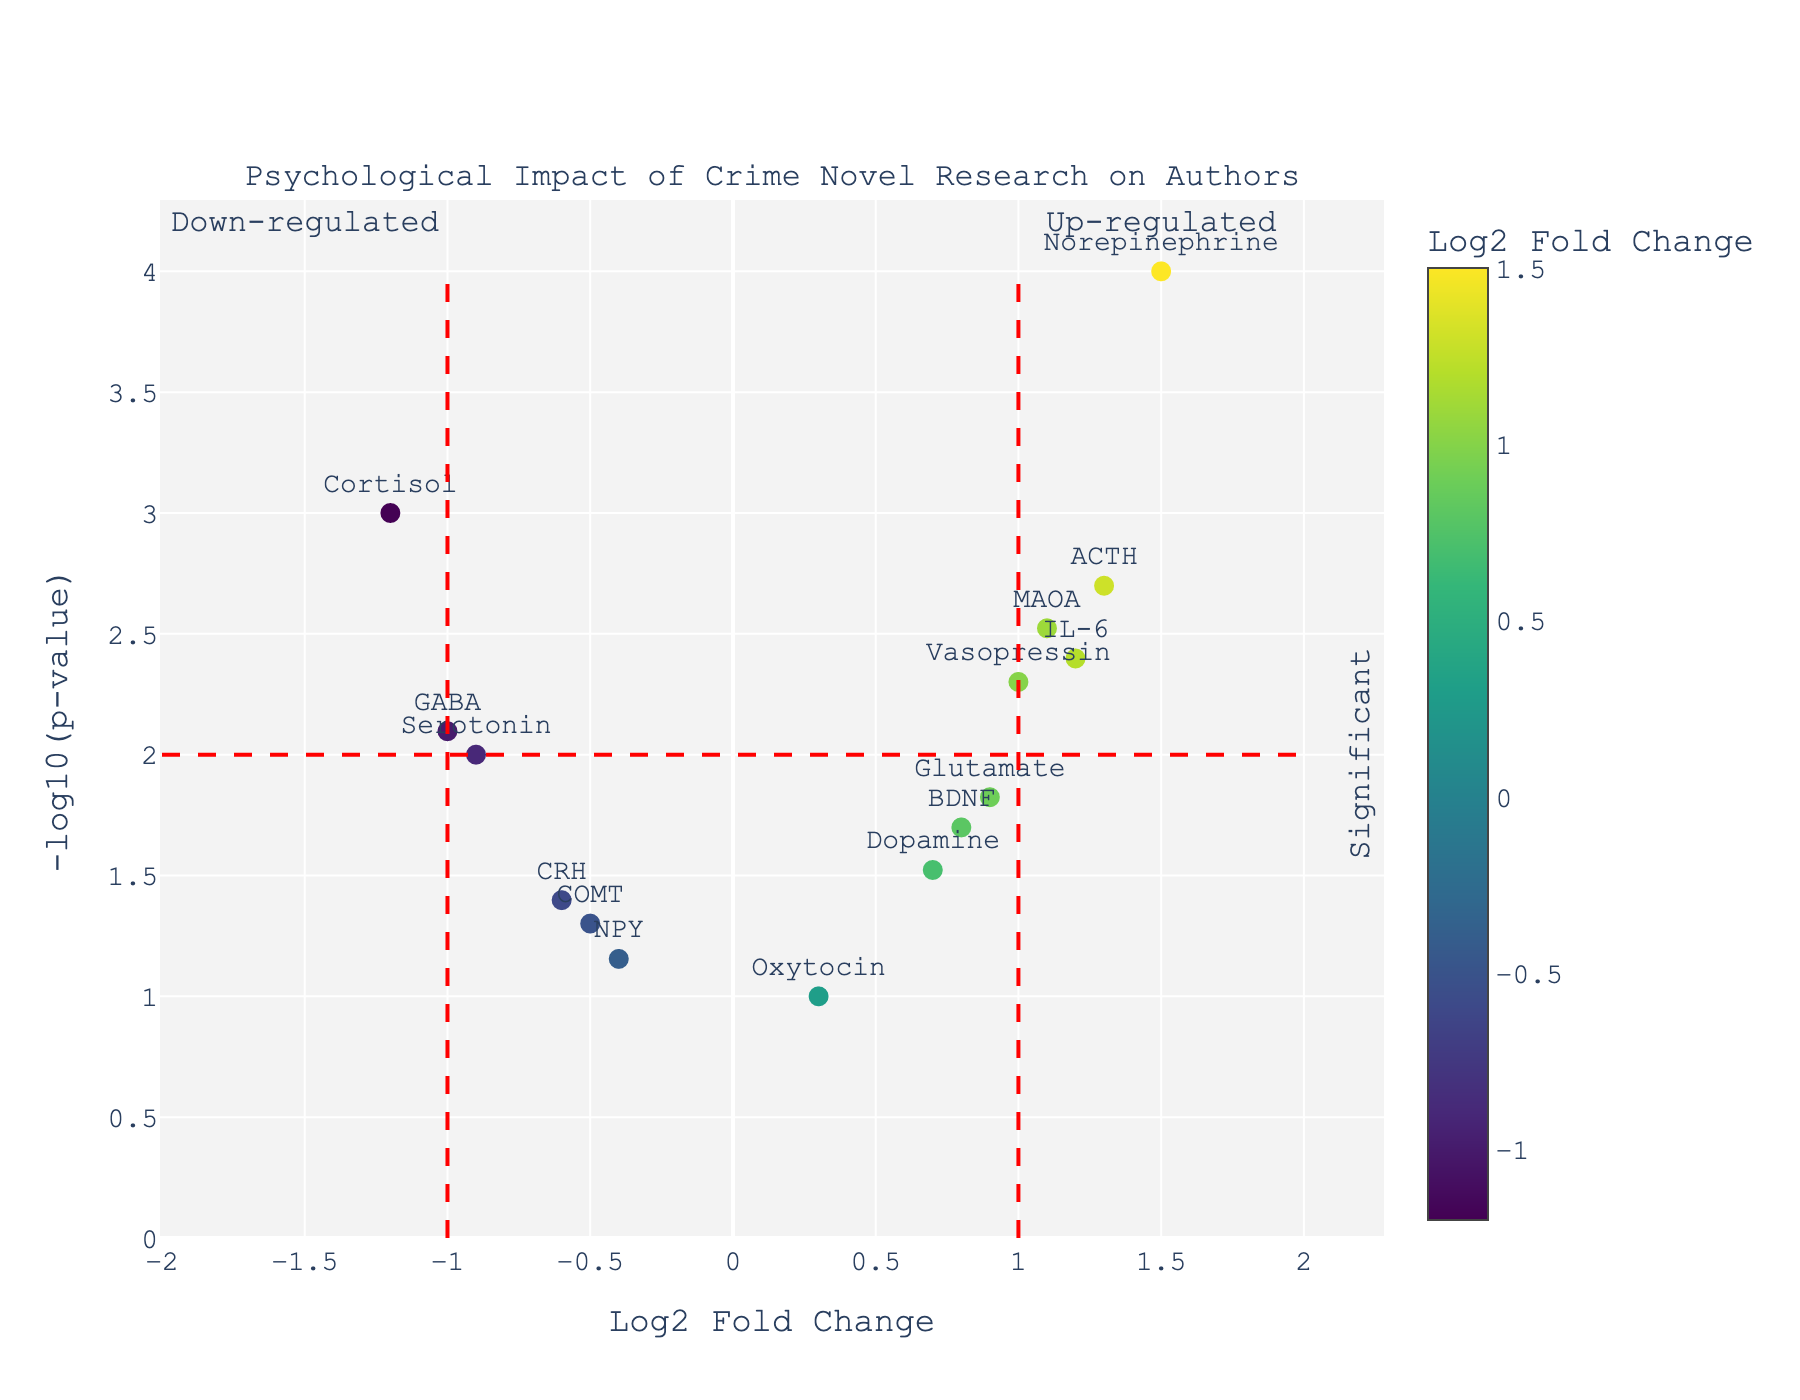How many genes are up-regulated? To determine the number of up-regulated genes, count the data points with a Log2 Fold Change value greater than zero in the figure.
Answer: 8 Which gene has the highest -log10(p-value)? From the plot, identify the gene with the highest y-axis value, which is -log10(p-value).
Answer: Norepinephrine What is the Log2 Fold Change value for Cortisol? On the x-axis, locate the data point labeled "Cortisol" and note its Log2 Fold Change value.
Answer: -1.2 Are there any genes that are significantly down-regulated? Significant genes are those with -log10(p-value) > 2. Down-regulated genes have a Log2 Fold Change < 0. Identify any genes meeting both criteria.
Answer: Yes, Cortisol and GABA How many genes have a p-value less than 0.01? Calculate -log10(0.01) to find the threshold on the y-axis and count the data points above this value.
Answer: 9 Compare the Log2 Fold Change of MAOA and Serotonin. Which one is higher? Locate MAOA and Serotonin on the x-axis and compare their Log2 Fold Change values.
Answer: MAOA What is the significance level (p-value) threshold for the horizontal red dashed line? The horizontal dashed line represents -log10(p-value) = 2. Convert this back to p-value using 10^-2.
Answer: 0.01 Which genes are near the threshold for being considered up-regulated? Identify genes with a Log2 Fold Change around 1 on the x-axis and their proximity to the vertical red dashed line at Log2 Fold Change = 1.
Answer: MAOA, Vasopressin, Glutamate What does the color gradient represent in the plot? Refer to the color bar in the plot which indicates the range of Log2 Fold Change values.
Answer: Log2 Fold Change values 